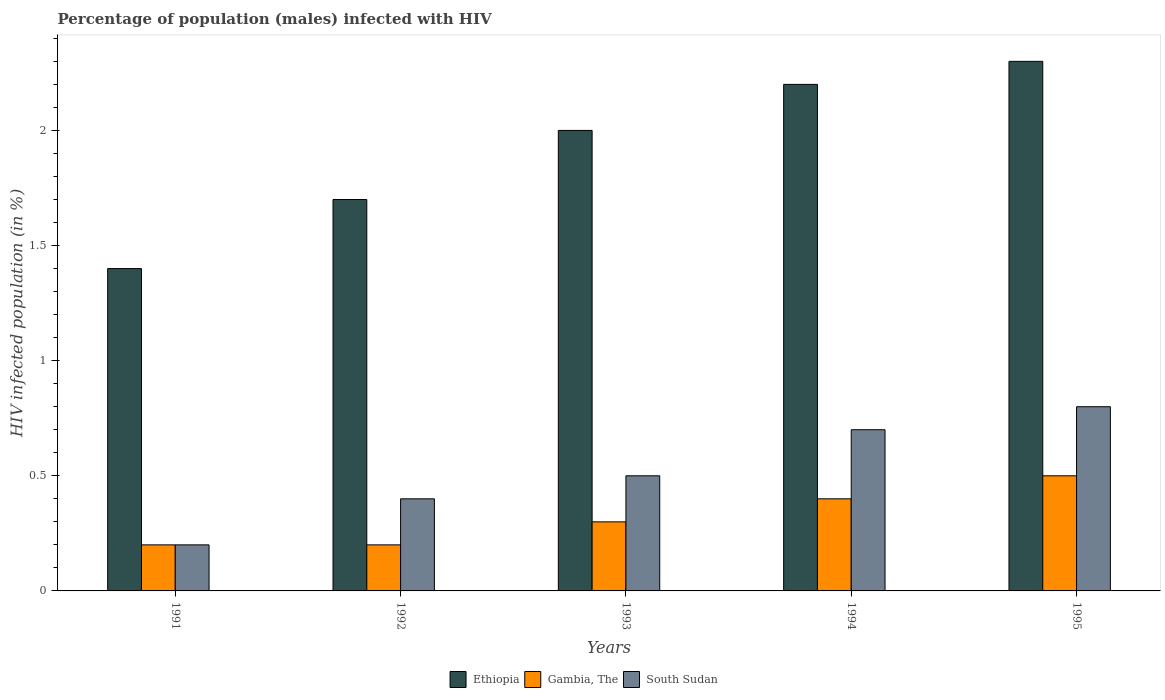Are the number of bars per tick equal to the number of legend labels?
Your response must be concise. Yes. How many bars are there on the 2nd tick from the left?
Offer a terse response. 3. How many bars are there on the 5th tick from the right?
Keep it short and to the point. 3. What is the label of the 2nd group of bars from the left?
Make the answer very short. 1992. What is the percentage of HIV infected male population in Ethiopia in 1992?
Give a very brief answer. 1.7. Across all years, what is the minimum percentage of HIV infected male population in Ethiopia?
Offer a terse response. 1.4. In which year was the percentage of HIV infected male population in South Sudan maximum?
Keep it short and to the point. 1995. What is the total percentage of HIV infected male population in Gambia, The in the graph?
Give a very brief answer. 1.6. What is the difference between the percentage of HIV infected male population in Ethiopia in 1993 and that in 1994?
Keep it short and to the point. -0.2. What is the difference between the percentage of HIV infected male population in Gambia, The in 1991 and the percentage of HIV infected male population in Ethiopia in 1995?
Provide a short and direct response. -2.1. What is the average percentage of HIV infected male population in South Sudan per year?
Offer a very short reply. 0.52. In the year 1995, what is the difference between the percentage of HIV infected male population in South Sudan and percentage of HIV infected male population in Gambia, The?
Make the answer very short. 0.3. In how many years, is the percentage of HIV infected male population in South Sudan greater than 0.5 %?
Your response must be concise. 2. What is the ratio of the percentage of HIV infected male population in Ethiopia in 1994 to that in 1995?
Make the answer very short. 0.96. Is the difference between the percentage of HIV infected male population in South Sudan in 1991 and 1992 greater than the difference between the percentage of HIV infected male population in Gambia, The in 1991 and 1992?
Offer a terse response. No. What is the difference between the highest and the second highest percentage of HIV infected male population in South Sudan?
Provide a succinct answer. 0.1. What is the difference between the highest and the lowest percentage of HIV infected male population in South Sudan?
Provide a short and direct response. 0.6. Is the sum of the percentage of HIV infected male population in South Sudan in 1992 and 1995 greater than the maximum percentage of HIV infected male population in Gambia, The across all years?
Provide a succinct answer. Yes. What does the 2nd bar from the left in 1992 represents?
Give a very brief answer. Gambia, The. What does the 2nd bar from the right in 1992 represents?
Provide a succinct answer. Gambia, The. Is it the case that in every year, the sum of the percentage of HIV infected male population in Ethiopia and percentage of HIV infected male population in Gambia, The is greater than the percentage of HIV infected male population in South Sudan?
Keep it short and to the point. Yes. What is the difference between two consecutive major ticks on the Y-axis?
Give a very brief answer. 0.5. Are the values on the major ticks of Y-axis written in scientific E-notation?
Your answer should be very brief. No. How many legend labels are there?
Give a very brief answer. 3. What is the title of the graph?
Ensure brevity in your answer.  Percentage of population (males) infected with HIV. What is the label or title of the X-axis?
Provide a succinct answer. Years. What is the label or title of the Y-axis?
Ensure brevity in your answer.  HIV infected population (in %). What is the HIV infected population (in %) of Ethiopia in 1991?
Provide a succinct answer. 1.4. What is the HIV infected population (in %) of Gambia, The in 1991?
Give a very brief answer. 0.2. What is the HIV infected population (in %) of Ethiopia in 1993?
Give a very brief answer. 2. What is the HIV infected population (in %) of Gambia, The in 1993?
Offer a very short reply. 0.3. What is the HIV infected population (in %) in South Sudan in 1993?
Offer a very short reply. 0.5. What is the HIV infected population (in %) in South Sudan in 1994?
Offer a very short reply. 0.7. What is the HIV infected population (in %) in Ethiopia in 1995?
Provide a short and direct response. 2.3. What is the HIV infected population (in %) of South Sudan in 1995?
Make the answer very short. 0.8. Across all years, what is the maximum HIV infected population (in %) of Ethiopia?
Your answer should be very brief. 2.3. Across all years, what is the maximum HIV infected population (in %) of Gambia, The?
Your answer should be compact. 0.5. Across all years, what is the minimum HIV infected population (in %) of Gambia, The?
Offer a terse response. 0.2. Across all years, what is the minimum HIV infected population (in %) of South Sudan?
Your answer should be compact. 0.2. What is the total HIV infected population (in %) in South Sudan in the graph?
Your response must be concise. 2.6. What is the difference between the HIV infected population (in %) in Ethiopia in 1991 and that in 1992?
Offer a very short reply. -0.3. What is the difference between the HIV infected population (in %) of South Sudan in 1991 and that in 1992?
Provide a short and direct response. -0.2. What is the difference between the HIV infected population (in %) in Ethiopia in 1991 and that in 1993?
Provide a short and direct response. -0.6. What is the difference between the HIV infected population (in %) of Gambia, The in 1991 and that in 1995?
Make the answer very short. -0.3. What is the difference between the HIV infected population (in %) of Ethiopia in 1992 and that in 1993?
Offer a terse response. -0.3. What is the difference between the HIV infected population (in %) of Gambia, The in 1992 and that in 1993?
Offer a terse response. -0.1. What is the difference between the HIV infected population (in %) of South Sudan in 1992 and that in 1993?
Keep it short and to the point. -0.1. What is the difference between the HIV infected population (in %) in Ethiopia in 1992 and that in 1994?
Keep it short and to the point. -0.5. What is the difference between the HIV infected population (in %) of Gambia, The in 1992 and that in 1994?
Give a very brief answer. -0.2. What is the difference between the HIV infected population (in %) of Ethiopia in 1992 and that in 1995?
Your answer should be very brief. -0.6. What is the difference between the HIV infected population (in %) of Gambia, The in 1992 and that in 1995?
Provide a succinct answer. -0.3. What is the difference between the HIV infected population (in %) of South Sudan in 1992 and that in 1995?
Keep it short and to the point. -0.4. What is the difference between the HIV infected population (in %) in Gambia, The in 1993 and that in 1994?
Give a very brief answer. -0.1. What is the difference between the HIV infected population (in %) of South Sudan in 1993 and that in 1994?
Offer a very short reply. -0.2. What is the difference between the HIV infected population (in %) of Ethiopia in 1993 and that in 1995?
Make the answer very short. -0.3. What is the difference between the HIV infected population (in %) in South Sudan in 1993 and that in 1995?
Offer a terse response. -0.3. What is the difference between the HIV infected population (in %) in Ethiopia in 1994 and that in 1995?
Provide a succinct answer. -0.1. What is the difference between the HIV infected population (in %) of South Sudan in 1994 and that in 1995?
Keep it short and to the point. -0.1. What is the difference between the HIV infected population (in %) of Gambia, The in 1991 and the HIV infected population (in %) of South Sudan in 1992?
Your answer should be very brief. -0.2. What is the difference between the HIV infected population (in %) of Ethiopia in 1991 and the HIV infected population (in %) of South Sudan in 1993?
Ensure brevity in your answer.  0.9. What is the difference between the HIV infected population (in %) in Gambia, The in 1991 and the HIV infected population (in %) in South Sudan in 1993?
Your answer should be very brief. -0.3. What is the difference between the HIV infected population (in %) of Ethiopia in 1991 and the HIV infected population (in %) of Gambia, The in 1994?
Offer a very short reply. 1. What is the difference between the HIV infected population (in %) of Ethiopia in 1992 and the HIV infected population (in %) of Gambia, The in 1993?
Provide a short and direct response. 1.4. What is the difference between the HIV infected population (in %) of Gambia, The in 1992 and the HIV infected population (in %) of South Sudan in 1993?
Your response must be concise. -0.3. What is the difference between the HIV infected population (in %) in Ethiopia in 1992 and the HIV infected population (in %) in Gambia, The in 1994?
Provide a short and direct response. 1.3. What is the difference between the HIV infected population (in %) of Ethiopia in 1992 and the HIV infected population (in %) of South Sudan in 1994?
Ensure brevity in your answer.  1. What is the difference between the HIV infected population (in %) in Gambia, The in 1992 and the HIV infected population (in %) in South Sudan in 1994?
Offer a very short reply. -0.5. What is the difference between the HIV infected population (in %) in Ethiopia in 1992 and the HIV infected population (in %) in Gambia, The in 1995?
Provide a succinct answer. 1.2. What is the difference between the HIV infected population (in %) in Gambia, The in 1992 and the HIV infected population (in %) in South Sudan in 1995?
Give a very brief answer. -0.6. What is the difference between the HIV infected population (in %) of Ethiopia in 1993 and the HIV infected population (in %) of Gambia, The in 1994?
Offer a terse response. 1.6. What is the difference between the HIV infected population (in %) in Ethiopia in 1993 and the HIV infected population (in %) in South Sudan in 1994?
Provide a short and direct response. 1.3. What is the difference between the HIV infected population (in %) in Gambia, The in 1993 and the HIV infected population (in %) in South Sudan in 1994?
Offer a terse response. -0.4. What is the difference between the HIV infected population (in %) in Gambia, The in 1994 and the HIV infected population (in %) in South Sudan in 1995?
Keep it short and to the point. -0.4. What is the average HIV infected population (in %) in Ethiopia per year?
Ensure brevity in your answer.  1.92. What is the average HIV infected population (in %) in Gambia, The per year?
Provide a short and direct response. 0.32. What is the average HIV infected population (in %) in South Sudan per year?
Offer a terse response. 0.52. In the year 1991, what is the difference between the HIV infected population (in %) in Ethiopia and HIV infected population (in %) in South Sudan?
Provide a short and direct response. 1.2. In the year 1992, what is the difference between the HIV infected population (in %) of Ethiopia and HIV infected population (in %) of Gambia, The?
Provide a short and direct response. 1.5. In the year 1994, what is the difference between the HIV infected population (in %) of Ethiopia and HIV infected population (in %) of South Sudan?
Keep it short and to the point. 1.5. In the year 1995, what is the difference between the HIV infected population (in %) in Ethiopia and HIV infected population (in %) in Gambia, The?
Give a very brief answer. 1.8. In the year 1995, what is the difference between the HIV infected population (in %) of Ethiopia and HIV infected population (in %) of South Sudan?
Make the answer very short. 1.5. What is the ratio of the HIV infected population (in %) in Ethiopia in 1991 to that in 1992?
Keep it short and to the point. 0.82. What is the ratio of the HIV infected population (in %) of Gambia, The in 1991 to that in 1992?
Ensure brevity in your answer.  1. What is the ratio of the HIV infected population (in %) in South Sudan in 1991 to that in 1993?
Keep it short and to the point. 0.4. What is the ratio of the HIV infected population (in %) of Ethiopia in 1991 to that in 1994?
Give a very brief answer. 0.64. What is the ratio of the HIV infected population (in %) in Gambia, The in 1991 to that in 1994?
Give a very brief answer. 0.5. What is the ratio of the HIV infected population (in %) of South Sudan in 1991 to that in 1994?
Make the answer very short. 0.29. What is the ratio of the HIV infected population (in %) in Ethiopia in 1991 to that in 1995?
Make the answer very short. 0.61. What is the ratio of the HIV infected population (in %) in South Sudan in 1991 to that in 1995?
Provide a short and direct response. 0.25. What is the ratio of the HIV infected population (in %) in South Sudan in 1992 to that in 1993?
Your answer should be very brief. 0.8. What is the ratio of the HIV infected population (in %) in Ethiopia in 1992 to that in 1994?
Your answer should be compact. 0.77. What is the ratio of the HIV infected population (in %) in Gambia, The in 1992 to that in 1994?
Your response must be concise. 0.5. What is the ratio of the HIV infected population (in %) in South Sudan in 1992 to that in 1994?
Your answer should be compact. 0.57. What is the ratio of the HIV infected population (in %) of Ethiopia in 1992 to that in 1995?
Keep it short and to the point. 0.74. What is the ratio of the HIV infected population (in %) of Gambia, The in 1992 to that in 1995?
Your answer should be very brief. 0.4. What is the ratio of the HIV infected population (in %) of South Sudan in 1992 to that in 1995?
Give a very brief answer. 0.5. What is the ratio of the HIV infected population (in %) of Ethiopia in 1993 to that in 1994?
Provide a succinct answer. 0.91. What is the ratio of the HIV infected population (in %) of Gambia, The in 1993 to that in 1994?
Offer a terse response. 0.75. What is the ratio of the HIV infected population (in %) of South Sudan in 1993 to that in 1994?
Offer a very short reply. 0.71. What is the ratio of the HIV infected population (in %) of Ethiopia in 1993 to that in 1995?
Keep it short and to the point. 0.87. What is the ratio of the HIV infected population (in %) of Ethiopia in 1994 to that in 1995?
Your response must be concise. 0.96. What is the ratio of the HIV infected population (in %) of South Sudan in 1994 to that in 1995?
Make the answer very short. 0.88. What is the difference between the highest and the second highest HIV infected population (in %) of Ethiopia?
Your response must be concise. 0.1. What is the difference between the highest and the lowest HIV infected population (in %) in Ethiopia?
Your answer should be compact. 0.9. What is the difference between the highest and the lowest HIV infected population (in %) of South Sudan?
Offer a terse response. 0.6. 